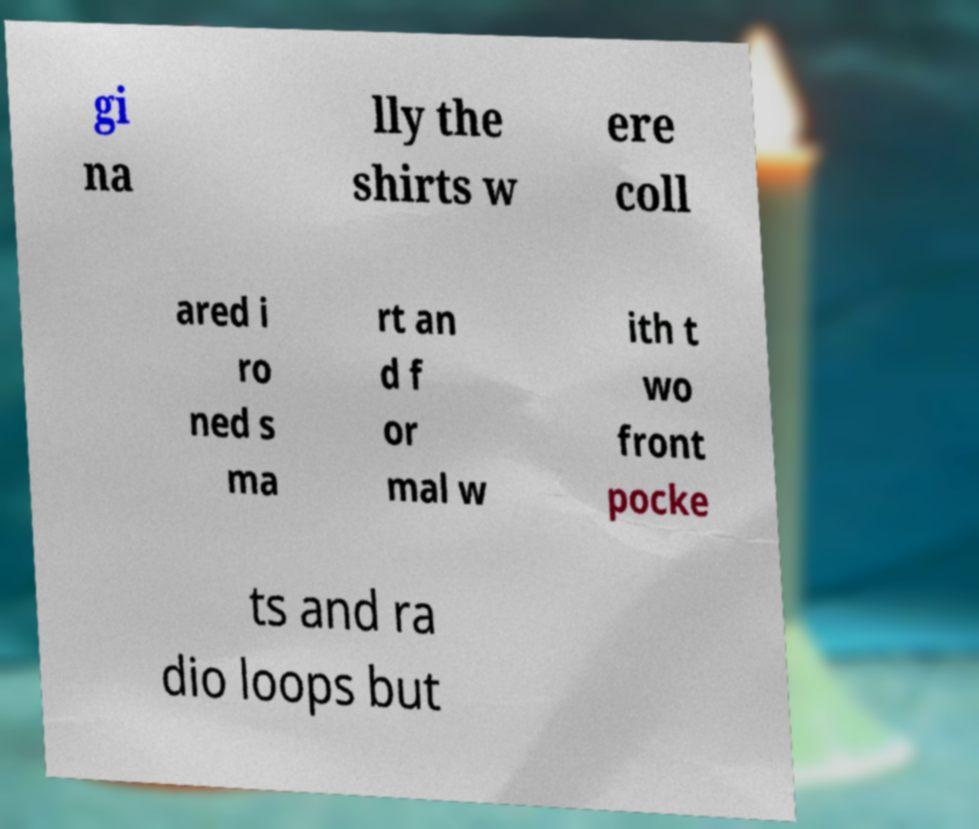For documentation purposes, I need the text within this image transcribed. Could you provide that? gi na lly the shirts w ere coll ared i ro ned s ma rt an d f or mal w ith t wo front pocke ts and ra dio loops but 